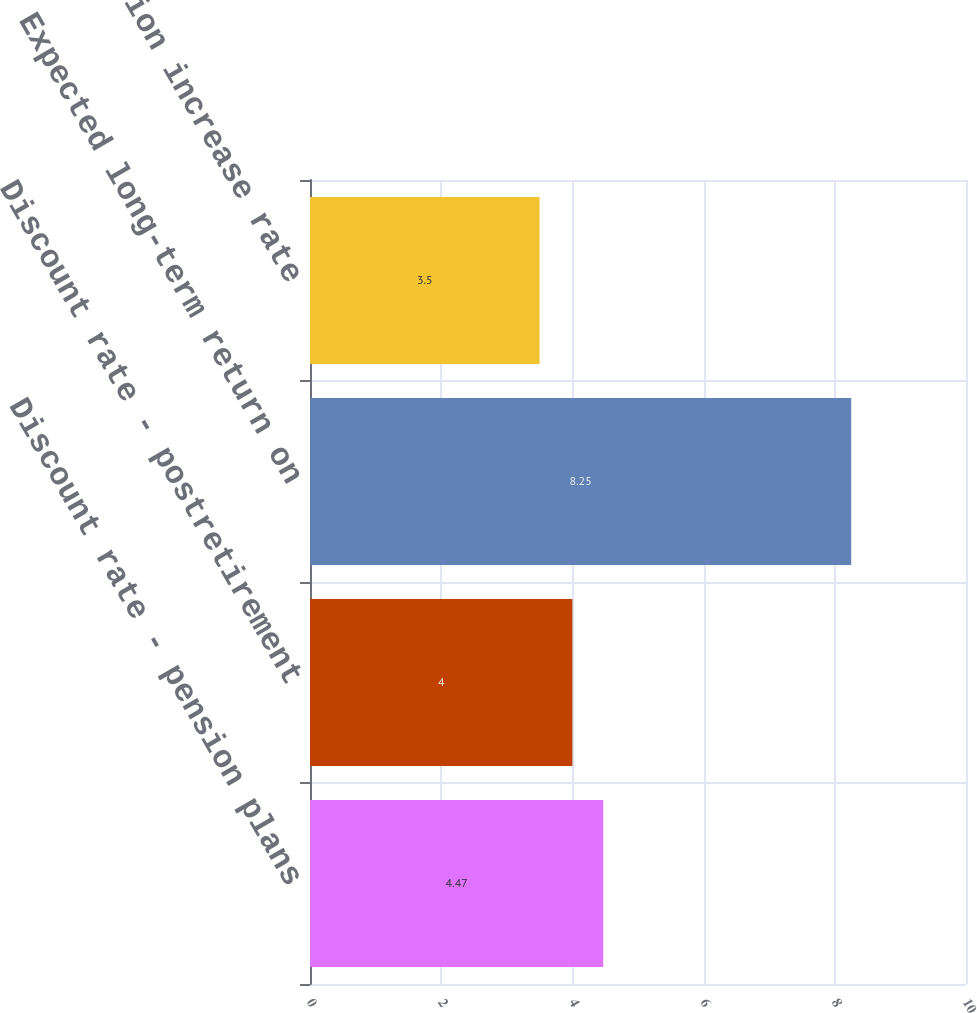Convert chart. <chart><loc_0><loc_0><loc_500><loc_500><bar_chart><fcel>Discount rate - pension plans<fcel>Discount rate - postretirement<fcel>Expected long-term return on<fcel>Compensation increase rate<nl><fcel>4.47<fcel>4<fcel>8.25<fcel>3.5<nl></chart> 